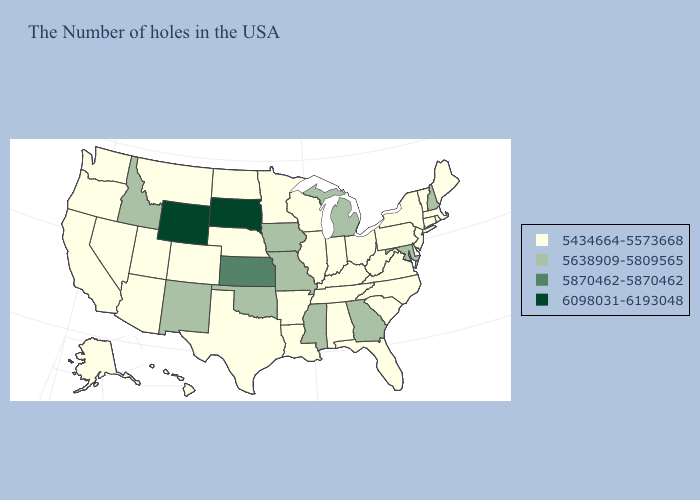What is the lowest value in the USA?
Answer briefly. 5434664-5573668. Which states have the lowest value in the USA?
Write a very short answer. Maine, Massachusetts, Rhode Island, Vermont, Connecticut, New York, New Jersey, Delaware, Pennsylvania, Virginia, North Carolina, South Carolina, West Virginia, Ohio, Florida, Kentucky, Indiana, Alabama, Tennessee, Wisconsin, Illinois, Louisiana, Arkansas, Minnesota, Nebraska, Texas, North Dakota, Colorado, Utah, Montana, Arizona, Nevada, California, Washington, Oregon, Alaska, Hawaii. Among the states that border Iowa , which have the lowest value?
Write a very short answer. Wisconsin, Illinois, Minnesota, Nebraska. Name the states that have a value in the range 5870462-5870462?
Short answer required. Kansas. Does the first symbol in the legend represent the smallest category?
Write a very short answer. Yes. Does Idaho have the lowest value in the USA?
Quick response, please. No. Is the legend a continuous bar?
Be succinct. No. Name the states that have a value in the range 5870462-5870462?
Write a very short answer. Kansas. Name the states that have a value in the range 5870462-5870462?
Concise answer only. Kansas. What is the highest value in states that border California?
Keep it brief. 5434664-5573668. Name the states that have a value in the range 5434664-5573668?
Write a very short answer. Maine, Massachusetts, Rhode Island, Vermont, Connecticut, New York, New Jersey, Delaware, Pennsylvania, Virginia, North Carolina, South Carolina, West Virginia, Ohio, Florida, Kentucky, Indiana, Alabama, Tennessee, Wisconsin, Illinois, Louisiana, Arkansas, Minnesota, Nebraska, Texas, North Dakota, Colorado, Utah, Montana, Arizona, Nevada, California, Washington, Oregon, Alaska, Hawaii. What is the value of New Mexico?
Give a very brief answer. 5638909-5809565. 